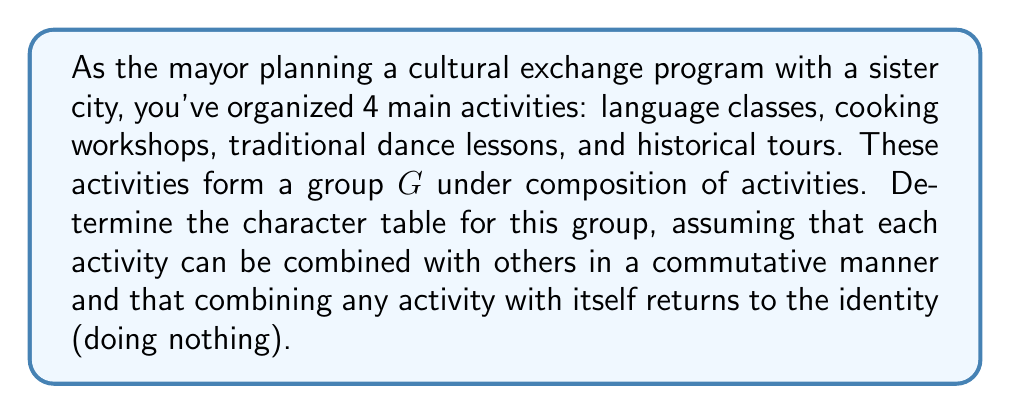Solve this math problem. Let's approach this step-by-step:

1) First, we need to identify the elements of the group $G$. Let's denote:
   $e$ = identity (doing nothing)
   $l$ = language classes
   $c$ = cooking workshops
   $d$ = dance lessons
   $h$ = historical tours

2) The group has 5 elements: $G = \{e, l, c, d, h\}$

3) Given the conditions, this group is isomorphic to $C_2 \times C_2$, where each non-identity element is its own inverse.

4) For $C_2 \times C_2$, we know there are 4 irreducible representations, all of degree 1.

5) To construct the character table, we need to find the conjugacy classes:
   $\{e\}$, $\{l\}$, $\{c\}$, $\{d\}$, $\{h\}$

6) The irreducible representations are:

   $\chi_1$: The trivial representation (all elements map to 1)
   $\chi_2$: $l$ and $c$ map to 1, $d$ and $h$ map to -1
   $\chi_3$: $l$ and $d$ map to 1, $c$ and $h$ map to -1
   $\chi_4$: $l$ and $h$ map to 1, $c$ and $d$ map to -1

7) We can now construct the character table:

   $$
   \begin{array}{c|ccccc}
    G & e & l & c & d & h \\
    \hline
    \chi_1 & 1 & 1 & 1 & 1 & 1 \\
    \chi_2 & 1 & 1 & 1 & -1 & -1 \\
    \chi_3 & 1 & 1 & -1 & 1 & -1 \\
    \chi_4 & 1 & 1 & -1 & -1 & 1
   \end{array}
   $$

This character table represents how each irreducible representation behaves for each element of the group, which in this context represents different combinations of cultural exchange activities.
Answer: $$
\begin{array}{c|ccccc}
G & e & l & c & d & h \\
\hline
\chi_1 & 1 & 1 & 1 & 1 & 1 \\
\chi_2 & 1 & 1 & 1 & -1 & -1 \\
\chi_3 & 1 & 1 & -1 & 1 & -1 \\
\chi_4 & 1 & 1 & -1 & -1 & 1
\end{array}
$$ 